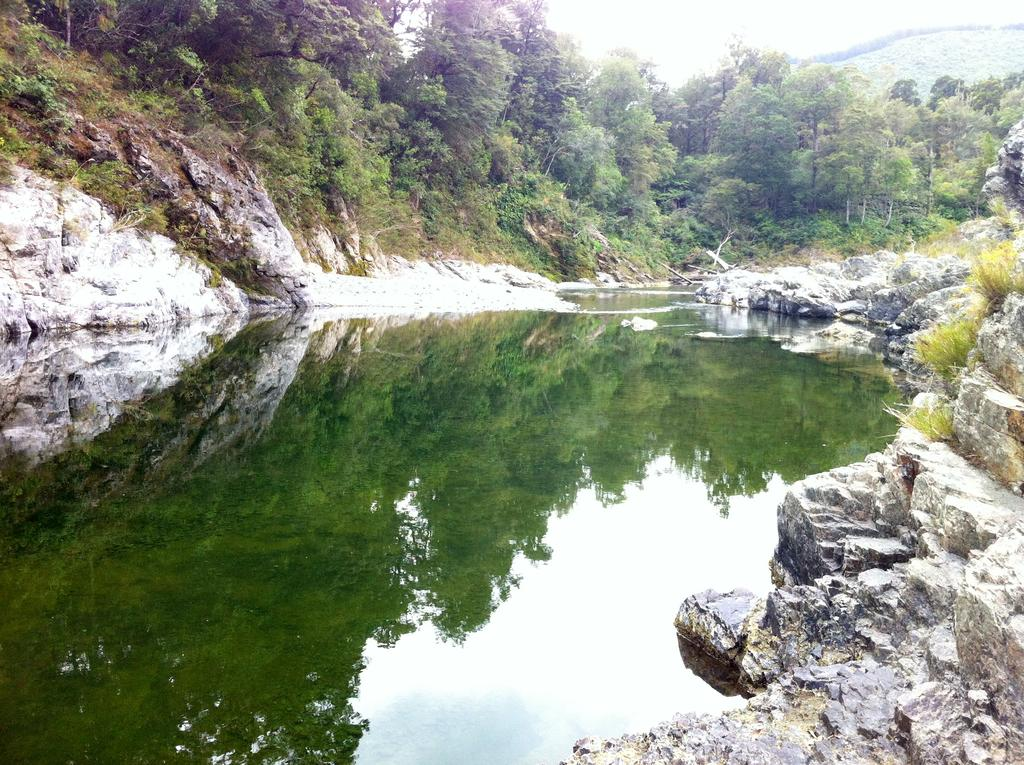What natural element is visible in the image? Water is visible in the image. What type of vegetation can be seen in the image? There are trees in the image. What geological features are present in the image? There are rocks in the image. What type of produce can be seen growing on the trees in the image? There is no produce visible on the trees in the image; only the trees themselves are present. What time of day is it in the image? The time of day cannot be determined from the image, as there are no specific indicators of time present. 